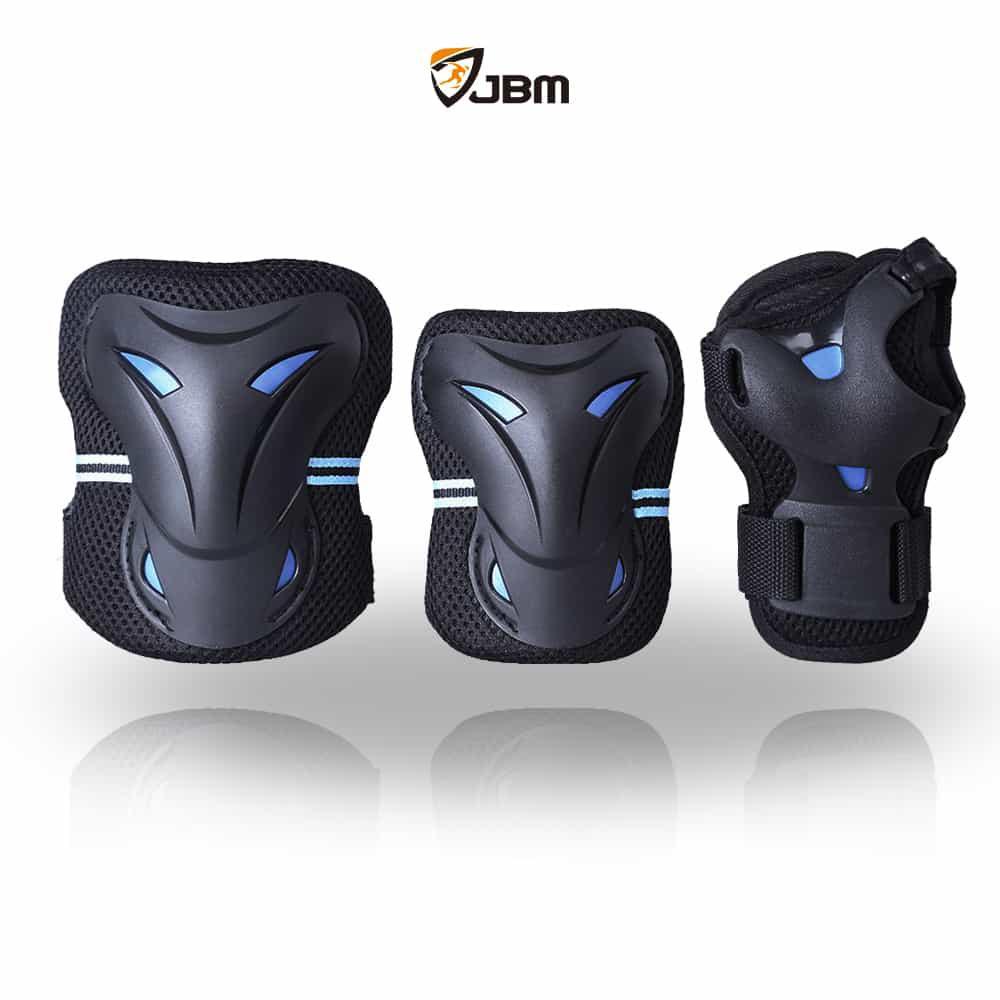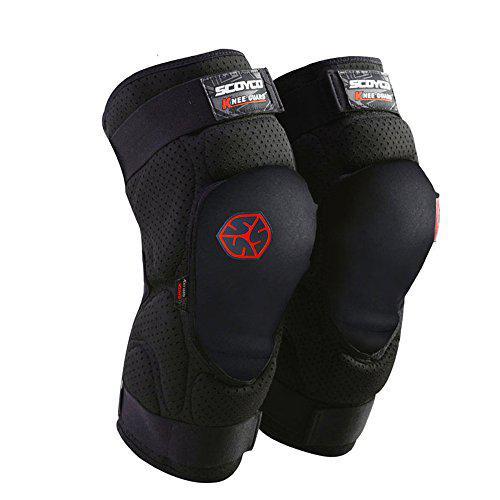The first image is the image on the left, the second image is the image on the right. Given the left and right images, does the statement "An image shows a line of three protective gear items, featuring round perforated pads for the knee and elbow." hold true? Answer yes or no. No. The first image is the image on the left, the second image is the image on the right. Given the left and right images, does the statement "There are no more than five knee braces." hold true? Answer yes or no. Yes. 